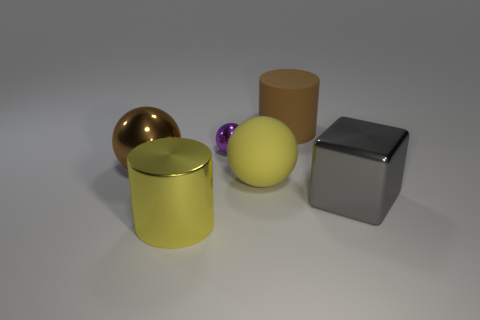What number of other purple balls are the same size as the rubber ball?
Give a very brief answer. 0. Is there a tiny cyan metal sphere?
Offer a terse response. No. Is there anything else that is the same color as the big metal block?
Your answer should be very brief. No. What shape is the purple object that is the same material as the big yellow cylinder?
Offer a very short reply. Sphere. There is a big rubber thing behind the matte thing to the left of the rubber cylinder that is behind the large yellow sphere; what color is it?
Ensure brevity in your answer.  Brown. Is the number of big brown shiny things on the right side of the small purple metal ball the same as the number of red matte cylinders?
Ensure brevity in your answer.  Yes. Is there anything else that has the same material as the small ball?
Your answer should be compact. Yes. There is a large metal sphere; does it have the same color as the large thing that is behind the tiny purple object?
Your answer should be compact. Yes. Are there any matte objects right of the yellow thing that is to the right of the large yellow object in front of the gray metal object?
Offer a terse response. Yes. Is the number of large brown shiny balls on the right side of the brown ball less than the number of red matte cubes?
Your response must be concise. No. 